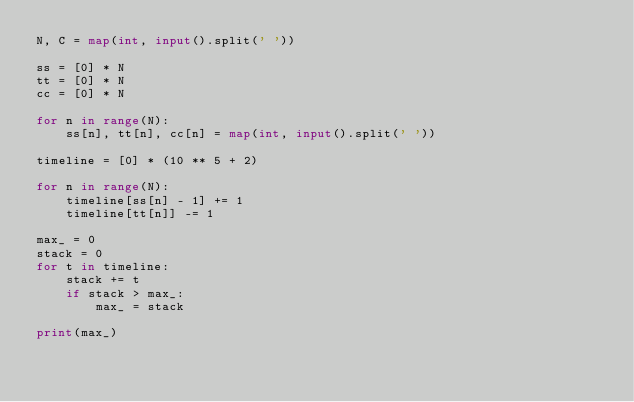<code> <loc_0><loc_0><loc_500><loc_500><_Python_>N, C = map(int, input().split(' '))

ss = [0] * N
tt = [0] * N
cc = [0] * N

for n in range(N):
    ss[n], tt[n], cc[n] = map(int, input().split(' '))

timeline = [0] * (10 ** 5 + 2)

for n in range(N):
    timeline[ss[n] - 1] += 1
    timeline[tt[n]] -= 1

max_ = 0
stack = 0
for t in timeline:
    stack += t
    if stack > max_:
        max_ = stack

print(max_)
</code> 